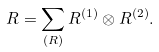Convert formula to latex. <formula><loc_0><loc_0><loc_500><loc_500>R = \sum _ { ( R ) } R ^ { ( 1 ) } \otimes R ^ { ( 2 ) } .</formula> 